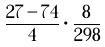<formula> <loc_0><loc_0><loc_500><loc_500>\frac { 2 7 - 7 4 } { 4 } \cdot \frac { 8 } { 2 9 8 }</formula> 